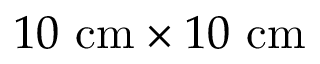<formula> <loc_0><loc_0><loc_500><loc_500>1 0 \ c m \times 1 0 \ c m</formula> 